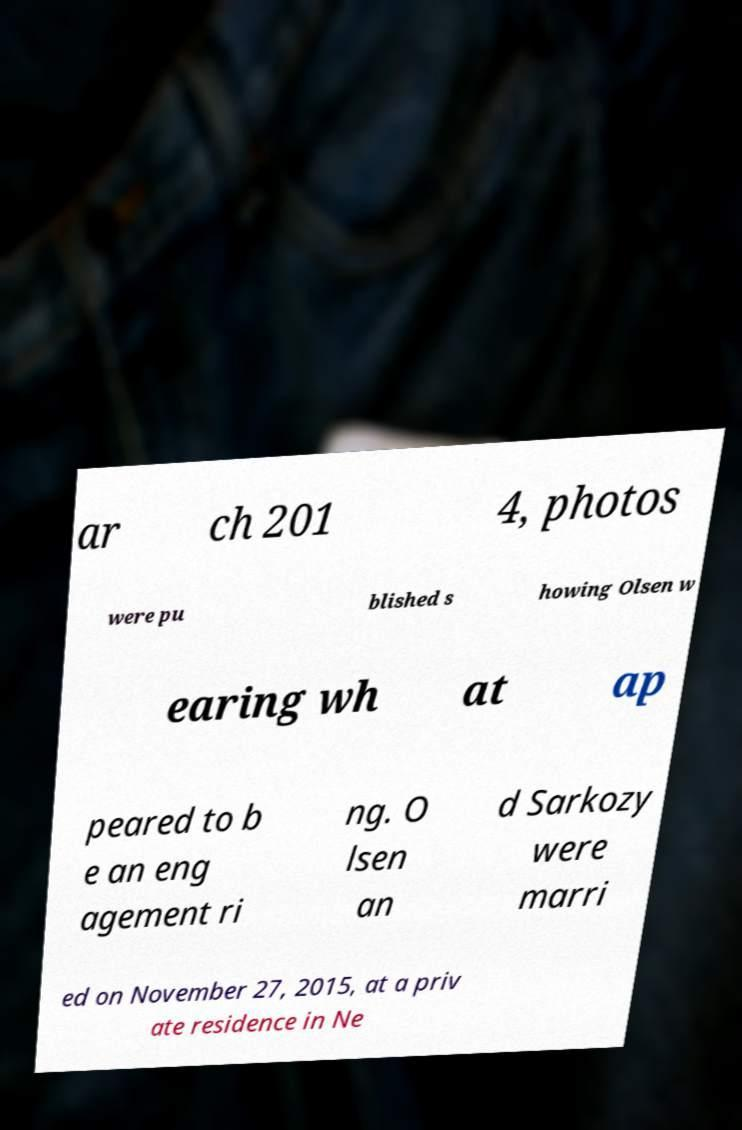Could you extract and type out the text from this image? ar ch 201 4, photos were pu blished s howing Olsen w earing wh at ap peared to b e an eng agement ri ng. O lsen an d Sarkozy were marri ed on November 27, 2015, at a priv ate residence in Ne 